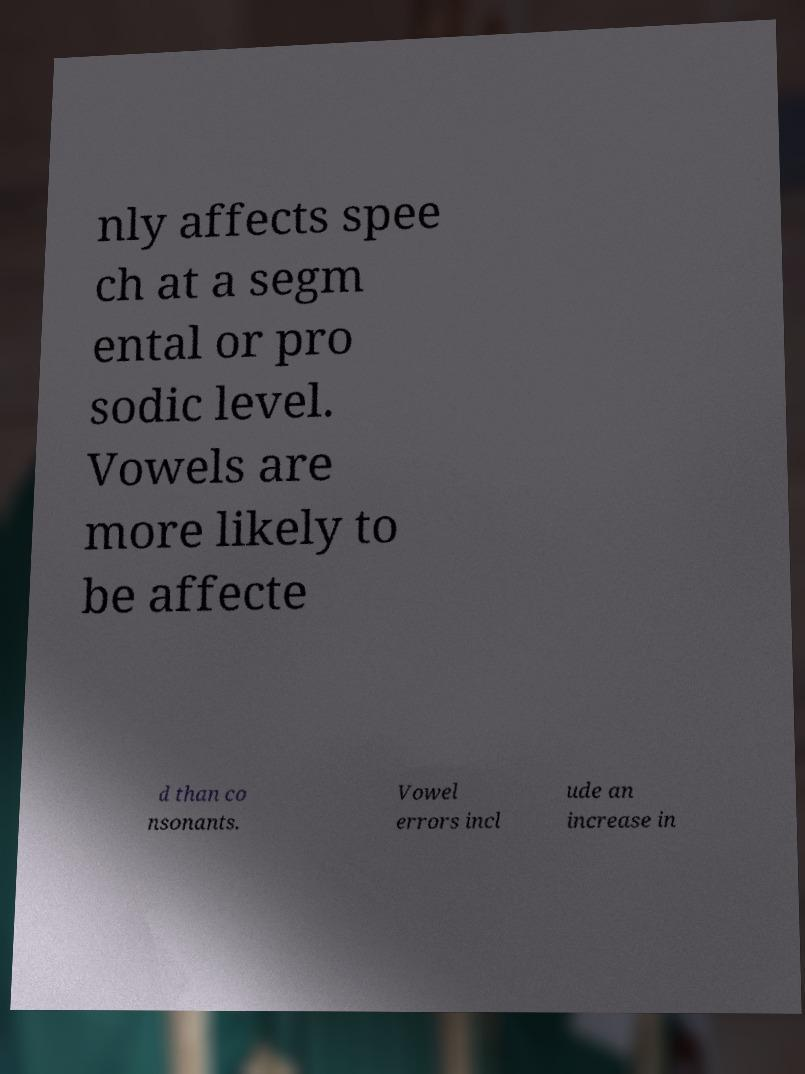Could you assist in decoding the text presented in this image and type it out clearly? nly affects spee ch at a segm ental or pro sodic level. Vowels are more likely to be affecte d than co nsonants. Vowel errors incl ude an increase in 